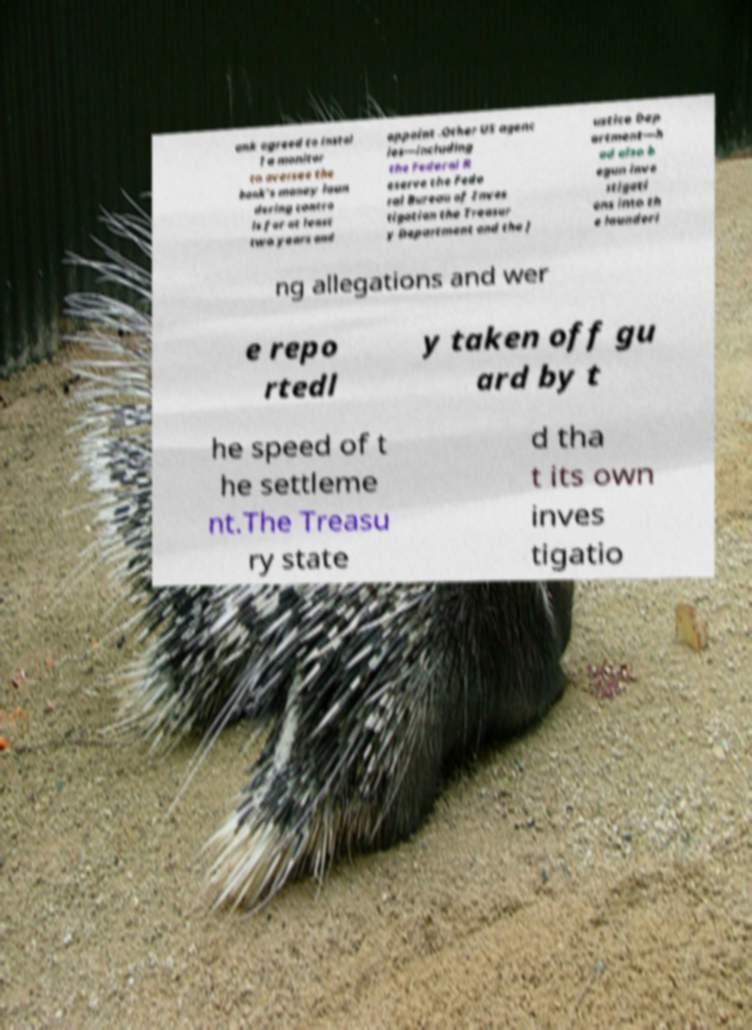What messages or text are displayed in this image? I need them in a readable, typed format. ank agreed to instal l a monitor to oversee the bank's money laun dering contro ls for at least two years and appoint .Other US agenc ies—including the Federal R eserve the Fede ral Bureau of Inves tigation the Treasur y Department and the J ustice Dep artment—h ad also b egun inve stigati ons into th e launderi ng allegations and wer e repo rtedl y taken off gu ard by t he speed of t he settleme nt.The Treasu ry state d tha t its own inves tigatio 